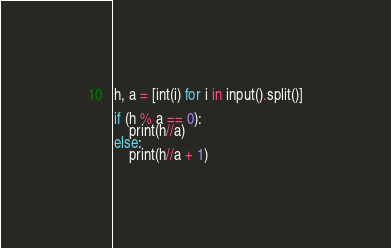<code> <loc_0><loc_0><loc_500><loc_500><_Python_>h, a = [int(i) for i in input().split()]

if (h % a == 0):
    print(h//a)
else:
    print(h//a + 1)
</code> 